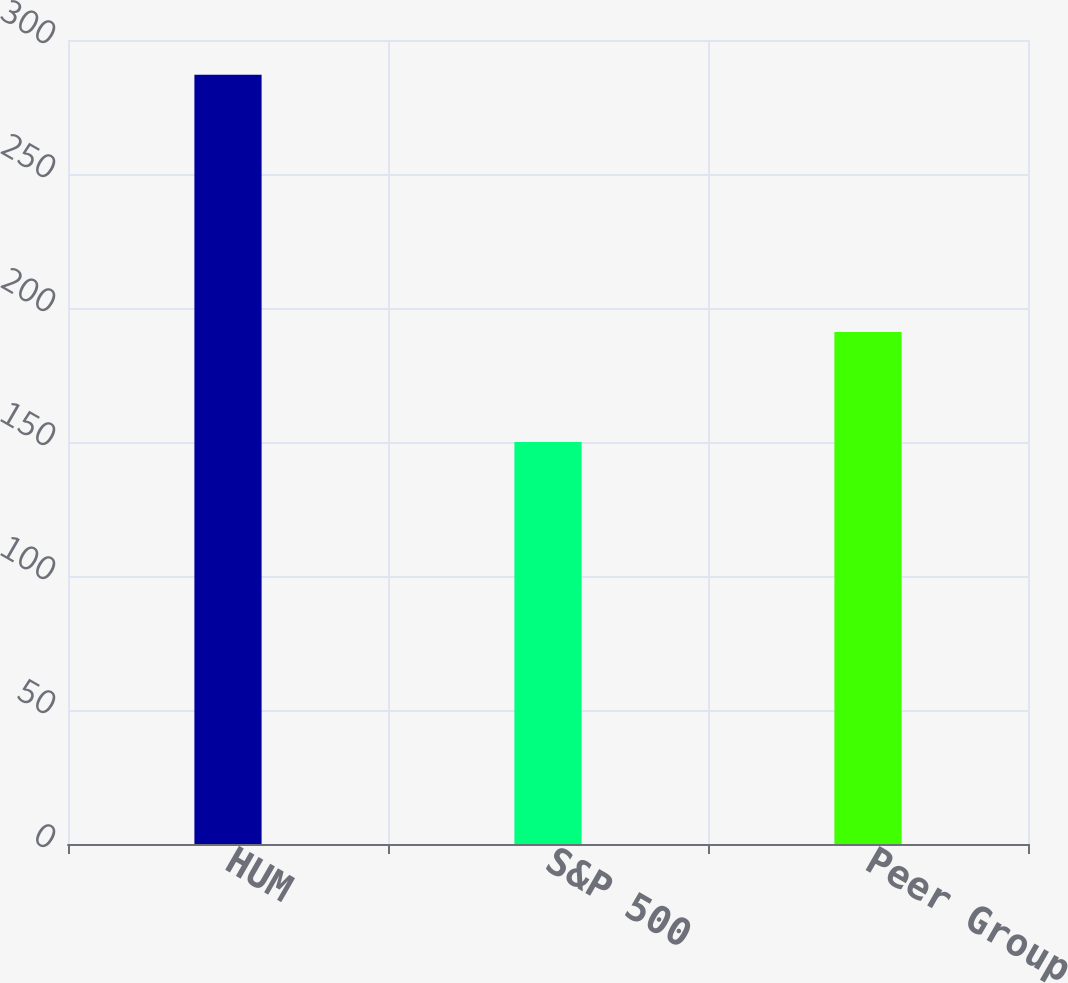Convert chart to OTSL. <chart><loc_0><loc_0><loc_500><loc_500><bar_chart><fcel>HUM<fcel>S&P 500<fcel>Peer Group<nl><fcel>287<fcel>150<fcel>191<nl></chart> 